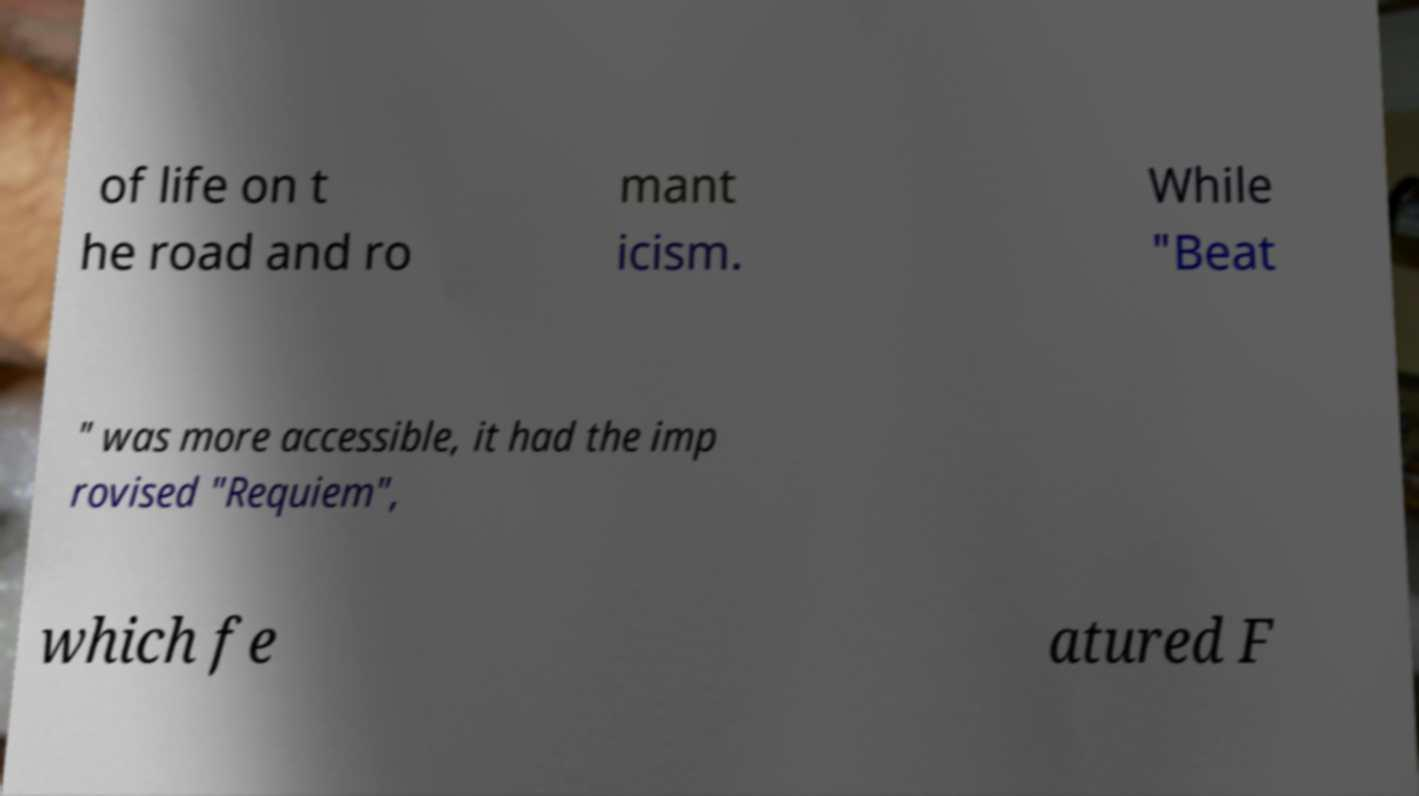I need the written content from this picture converted into text. Can you do that? of life on t he road and ro mant icism. While "Beat " was more accessible, it had the imp rovised "Requiem", which fe atured F 